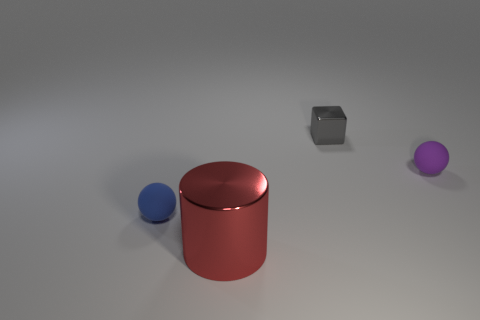Is there anything else that has the same size as the blue object?
Provide a succinct answer. Yes. The blue object is what size?
Keep it short and to the point. Small. There is a object that is in front of the small blue rubber sphere; what is its shape?
Keep it short and to the point. Cylinder. Is the small blue thing the same shape as the red object?
Give a very brief answer. No. Are there an equal number of shiny things in front of the block and tiny blue cylinders?
Keep it short and to the point. No. What shape is the large red metal object?
Provide a succinct answer. Cylinder. Is there any other thing of the same color as the cube?
Provide a succinct answer. No. Does the metallic object that is on the right side of the metallic cylinder have the same size as the rubber thing on the right side of the gray metallic block?
Offer a terse response. Yes. What is the shape of the tiny object in front of the sphere that is behind the blue object?
Make the answer very short. Sphere. Is the size of the gray metallic cube the same as the rubber object that is on the left side of the red thing?
Your answer should be compact. Yes. 